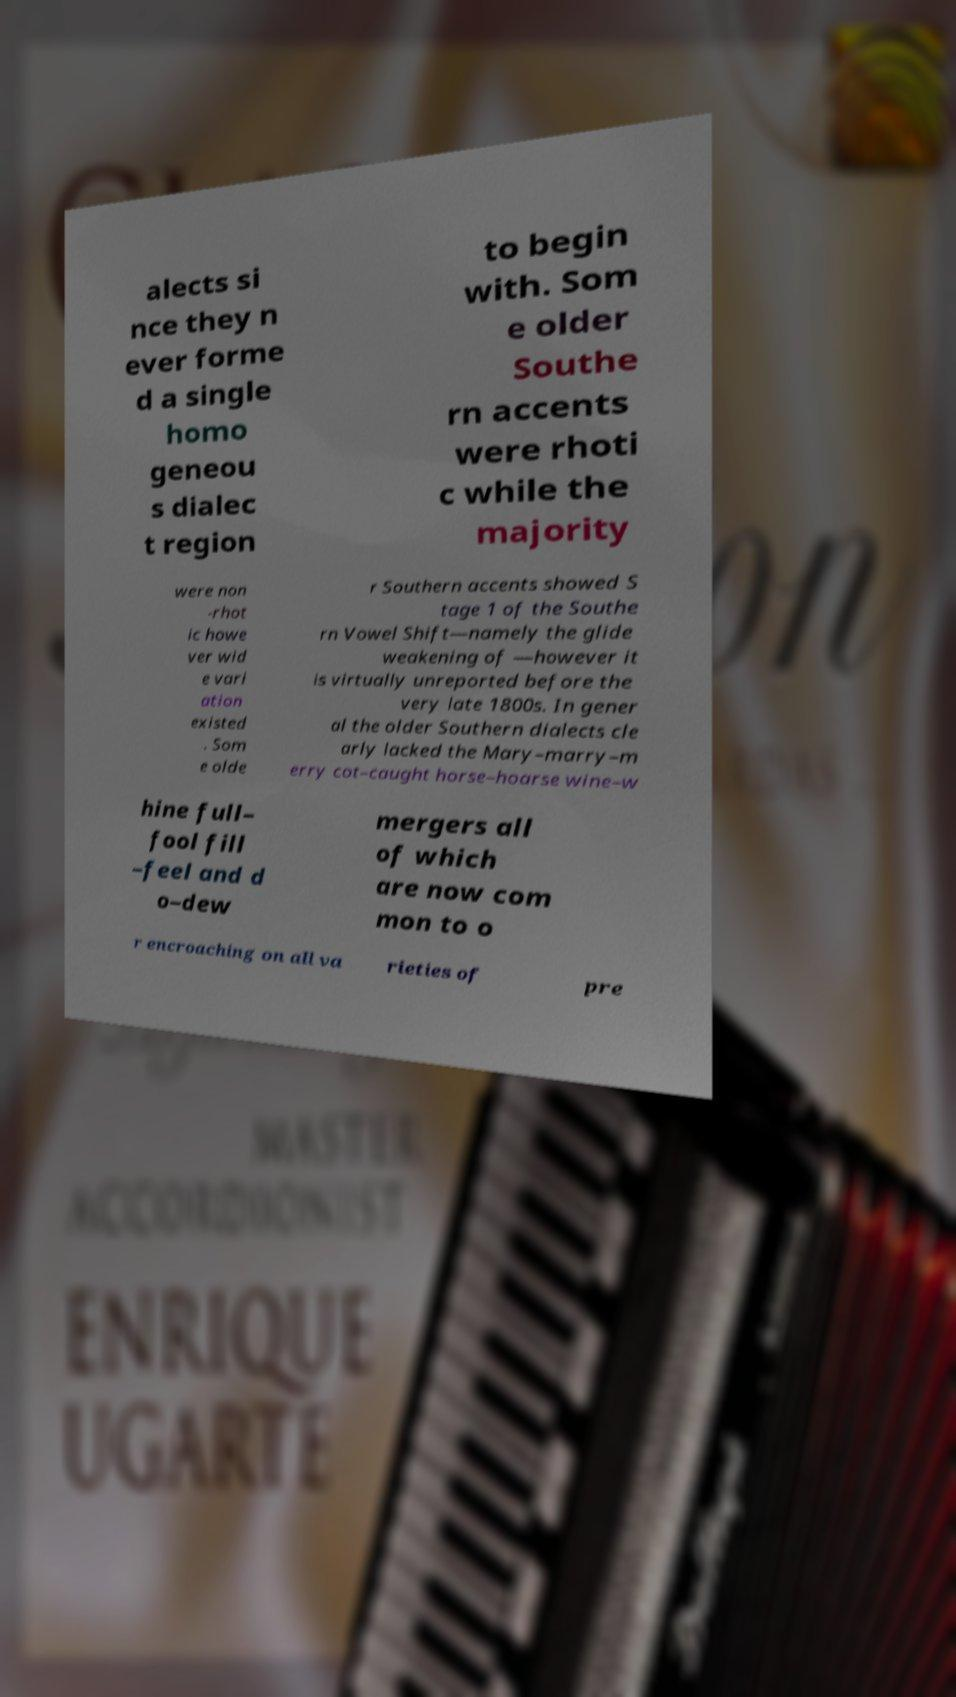There's text embedded in this image that I need extracted. Can you transcribe it verbatim? alects si nce they n ever forme d a single homo geneou s dialec t region to begin with. Som e older Southe rn accents were rhoti c while the majority were non -rhot ic howe ver wid e vari ation existed . Som e olde r Southern accents showed S tage 1 of the Southe rn Vowel Shift—namely the glide weakening of —however it is virtually unreported before the very late 1800s. In gener al the older Southern dialects cle arly lacked the Mary–marry–m erry cot–caught horse–hoarse wine–w hine full– fool fill –feel and d o–dew mergers all of which are now com mon to o r encroaching on all va rieties of pre 